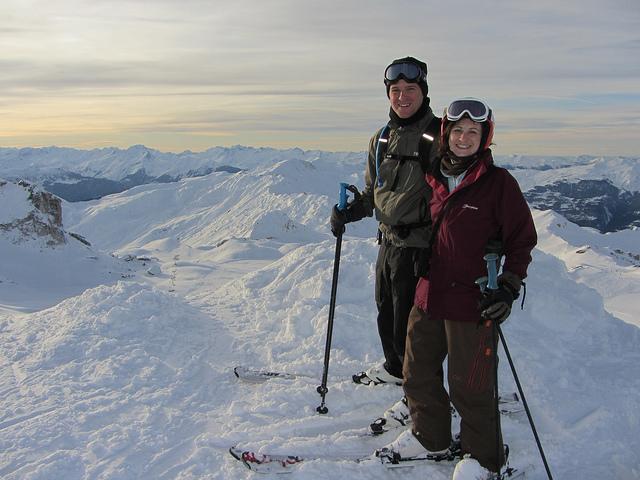Are these people dressed appropriately for their environment?
Give a very brief answer. Yes. What does the man have on his face?
Concise answer only. Goggles. Is the man wearing sunglasses?
Write a very short answer. No. How many poles is she holding?
Write a very short answer. 1. What safety precautions are being used?
Keep it brief. Goggles. What is on the snowboarders head?
Answer briefly. Goggles. Where are they standing?
Be succinct. Mountain. Is everyone looking at the camera?
Give a very brief answer. Yes. From which direction is the sun shining?
Concise answer only. Left. What are they wearing on their heads?
Keep it brief. Goggles. 